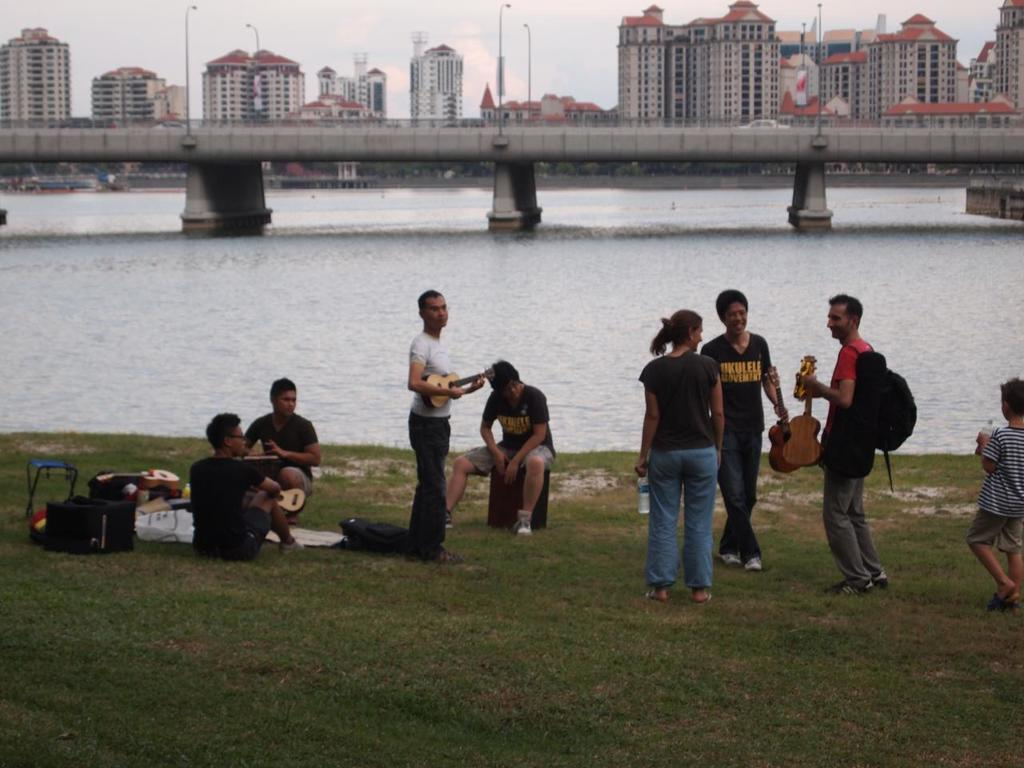What are the people in the image doing? Some people are sitting, and some are holding musical instruments. What can be seen in the background of the image? There are buildings, windows, light poles, and a bridge visible in the background. What is the condition of the water in the image? The water is present in the image, but its condition is not specified. What is the color of the sky in the image? The sky appears to be white in color. What type of popcorn is being served at the concert in the image? There is no concert or popcorn present in the image. What is the source of pleasure for the people in the image? The image does not specify the source of pleasure for the people; they could be enjoying various activities or experiences. 